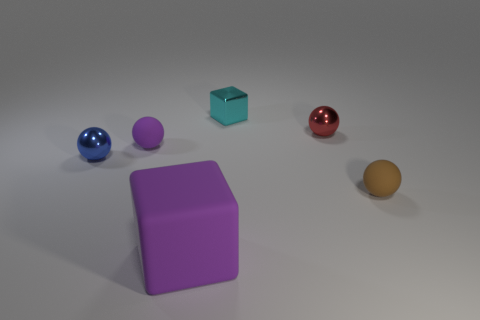Are there any other things that have the same size as the rubber block?
Provide a succinct answer. No. Is there another tiny metal thing that has the same shape as the tiny purple thing?
Provide a succinct answer. Yes. Do the blue ball and the rubber thing that is right of the big purple rubber thing have the same size?
Provide a succinct answer. Yes. How many objects are tiny objects in front of the blue ball or tiny objects in front of the small red metal thing?
Give a very brief answer. 3. Are there more spheres in front of the red metal ball than brown things?
Your answer should be compact. Yes. What number of purple things are the same size as the cyan object?
Ensure brevity in your answer.  1. Do the matte ball that is to the left of the small brown ball and the block to the left of the small cyan object have the same size?
Your answer should be compact. No. What size is the metal ball on the left side of the small cyan metallic object?
Keep it short and to the point. Small. What is the size of the cube that is in front of the tiny metal thing that is in front of the small purple thing?
Your response must be concise. Large. There is a block that is the same size as the brown thing; what material is it?
Provide a short and direct response. Metal. 